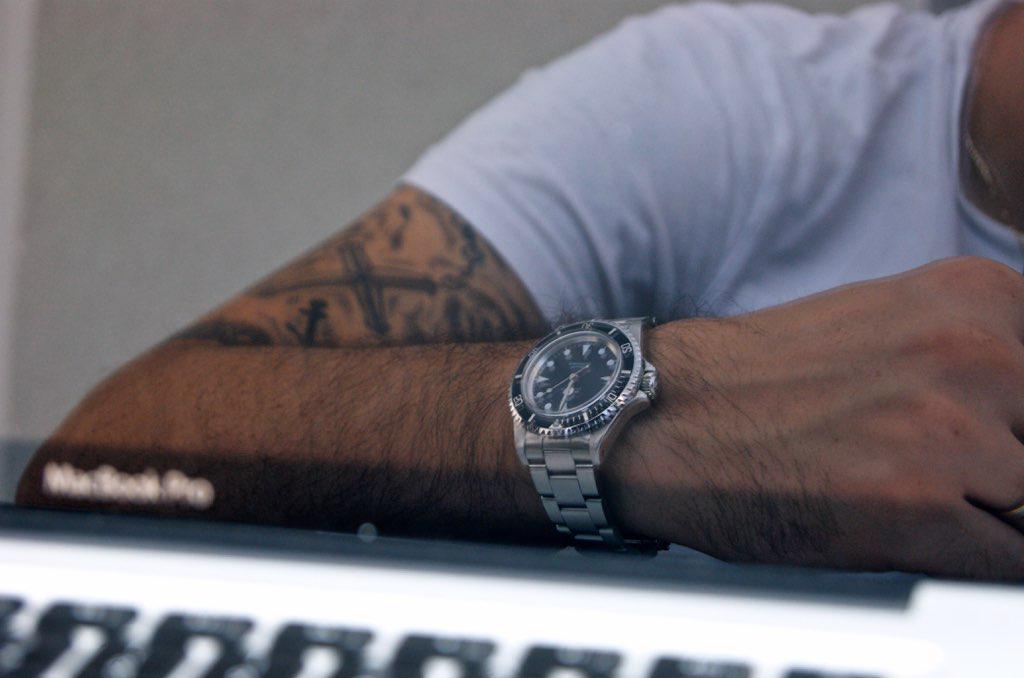Describe this image in one or two sentences. In this image I can see the person wearing the white color t-shirt and the watch. I can see the person is having the tattoo to the right hand. In-front of the person there is a white and black color object. In the background I can see the wall. 